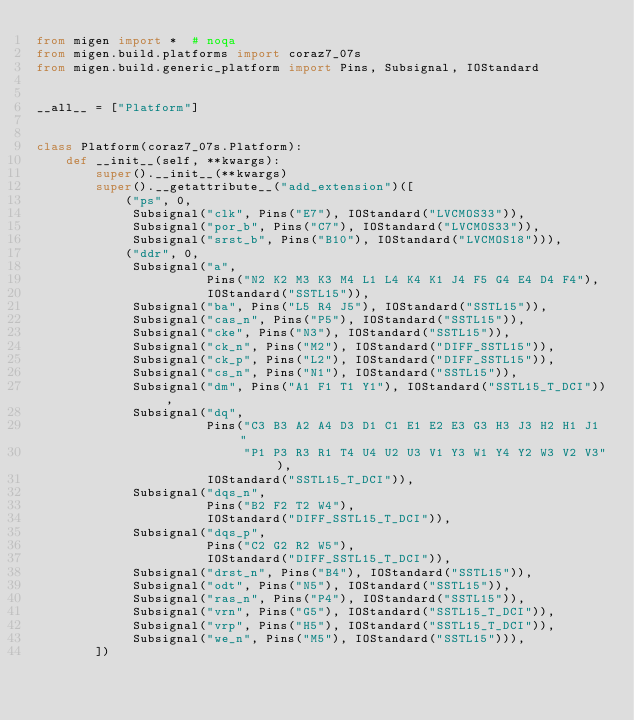Convert code to text. <code><loc_0><loc_0><loc_500><loc_500><_Python_>from migen import *  # noqa
from migen.build.platforms import coraz7_07s
from migen.build.generic_platform import Pins, Subsignal, IOStandard


__all__ = ["Platform"]


class Platform(coraz7_07s.Platform):
    def __init__(self, **kwargs):
        super().__init__(**kwargs)
        super().__getattribute__("add_extension")([
            ("ps", 0,
             Subsignal("clk", Pins("E7"), IOStandard("LVCMOS33")),
             Subsignal("por_b", Pins("C7"), IOStandard("LVCMOS33")),
             Subsignal("srst_b", Pins("B10"), IOStandard("LVCMOS18"))),
            ("ddr", 0,
             Subsignal("a",
                       Pins("N2 K2 M3 K3 M4 L1 L4 K4 K1 J4 F5 G4 E4 D4 F4"),
                       IOStandard("SSTL15")),
             Subsignal("ba", Pins("L5 R4 J5"), IOStandard("SSTL15")),
             Subsignal("cas_n", Pins("P5"), IOStandard("SSTL15")),
             Subsignal("cke", Pins("N3"), IOStandard("SSTL15")),
             Subsignal("ck_n", Pins("M2"), IOStandard("DIFF_SSTL15")),
             Subsignal("ck_p", Pins("L2"), IOStandard("DIFF_SSTL15")),
             Subsignal("cs_n", Pins("N1"), IOStandard("SSTL15")),
             Subsignal("dm", Pins("A1 F1 T1 Y1"), IOStandard("SSTL15_T_DCI")),
             Subsignal("dq",
                       Pins("C3 B3 A2 A4 D3 D1 C1 E1 E2 E3 G3 H3 J3 H2 H1 J1 "
                            "P1 P3 R3 R1 T4 U4 U2 U3 V1 Y3 W1 Y4 Y2 W3 V2 V3"),
                       IOStandard("SSTL15_T_DCI")),
             Subsignal("dqs_n",
                       Pins("B2 F2 T2 W4"),
                       IOStandard("DIFF_SSTL15_T_DCI")),
             Subsignal("dqs_p",
                       Pins("C2 G2 R2 W5"),
                       IOStandard("DIFF_SSTL15_T_DCI")),
             Subsignal("drst_n", Pins("B4"), IOStandard("SSTL15")),
             Subsignal("odt", Pins("N5"), IOStandard("SSTL15")),
             Subsignal("ras_n", Pins("P4"), IOStandard("SSTL15")),
             Subsignal("vrn", Pins("G5"), IOStandard("SSTL15_T_DCI")),
             Subsignal("vrp", Pins("H5"), IOStandard("SSTL15_T_DCI")),
             Subsignal("we_n", Pins("M5"), IOStandard("SSTL15"))),
        ])
</code> 